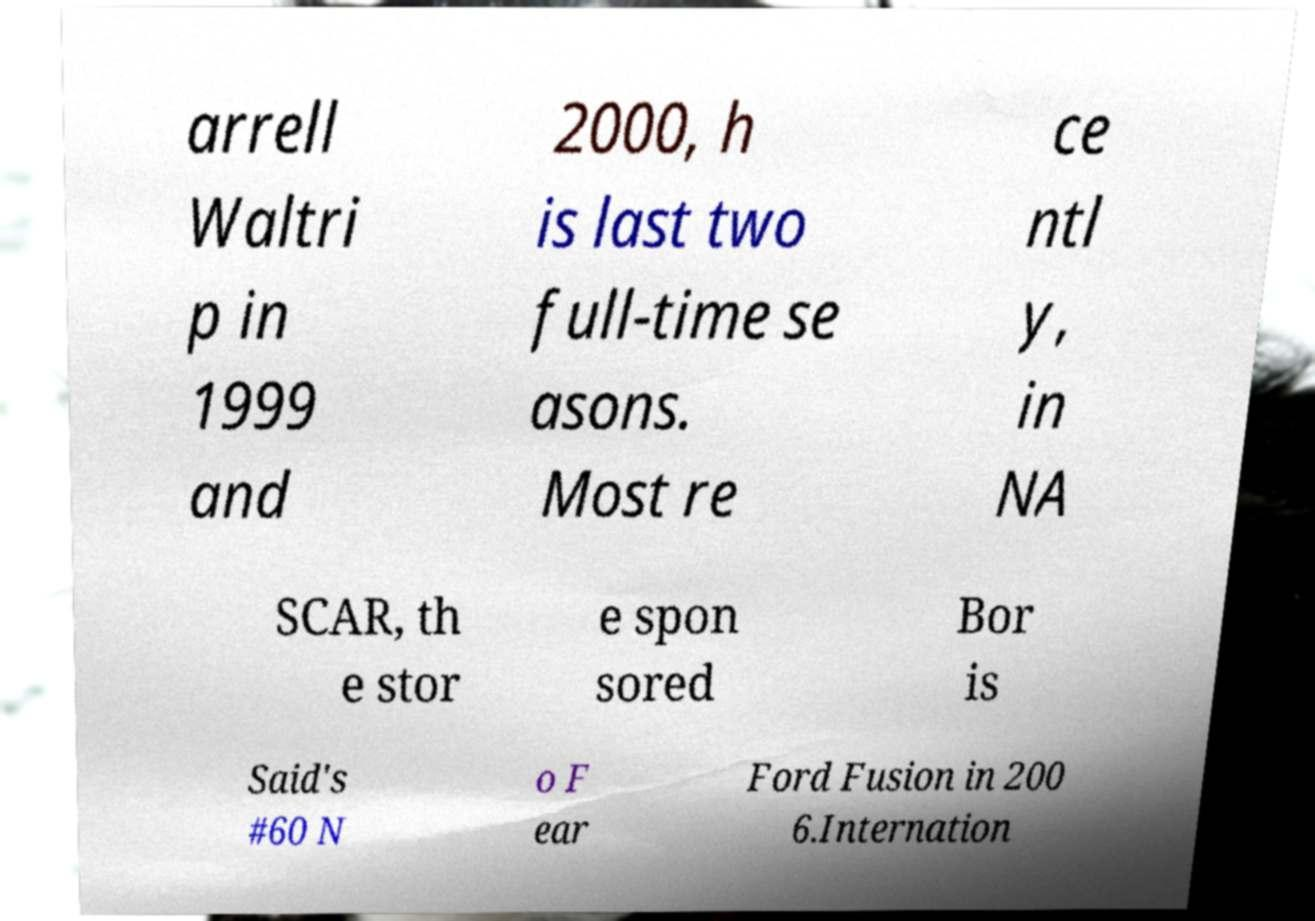Could you assist in decoding the text presented in this image and type it out clearly? arrell Waltri p in 1999 and 2000, h is last two full-time se asons. Most re ce ntl y, in NA SCAR, th e stor e spon sored Bor is Said's #60 N o F ear Ford Fusion in 200 6.Internation 